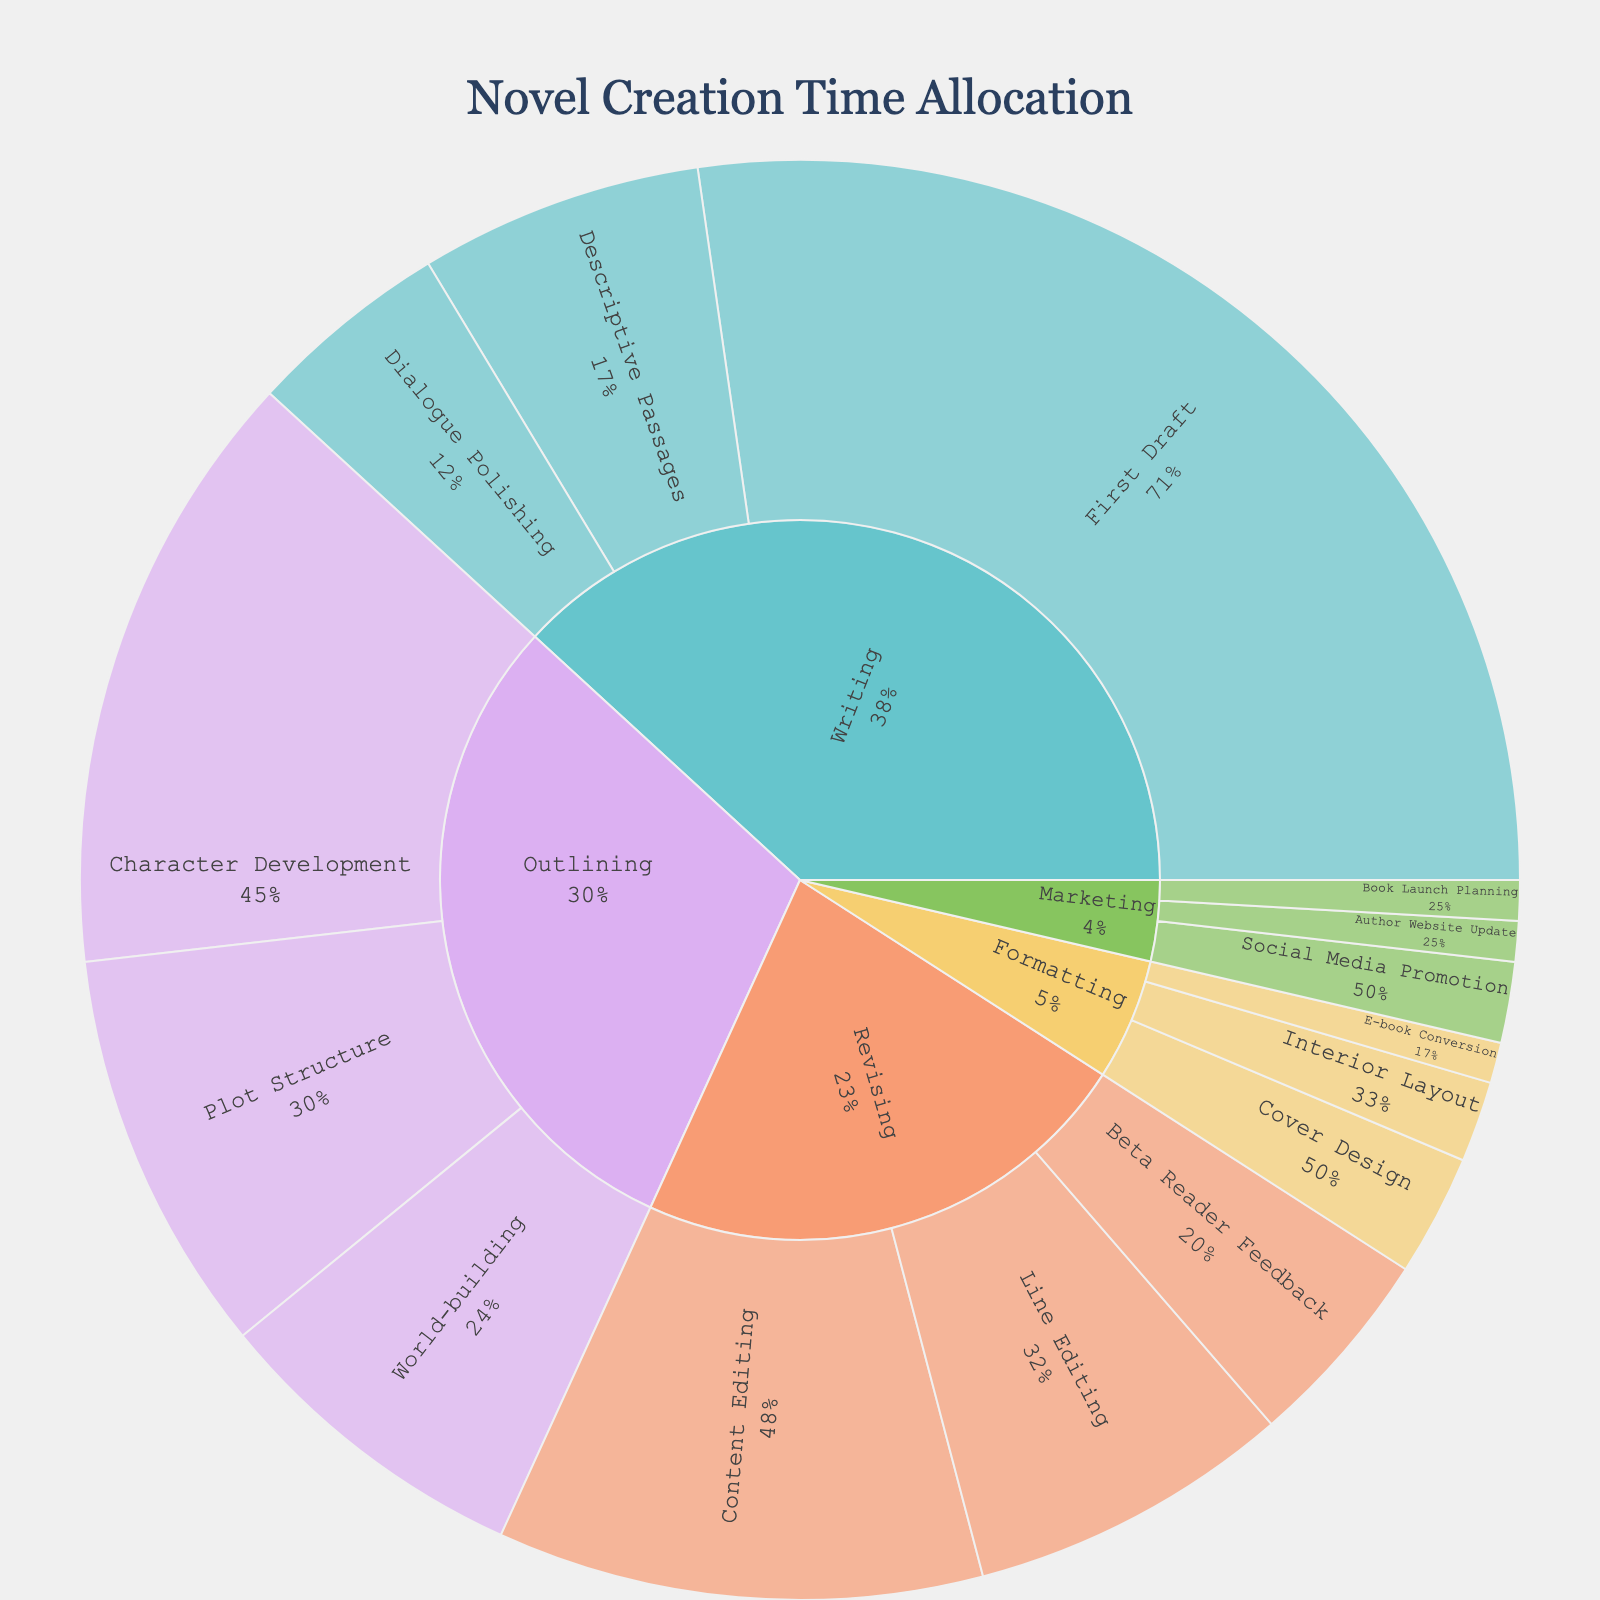What's the main title of the Sunburst Plot? Look at the top of the plot where the title is usually displayed to find the main title.
Answer: Novel Creation Time Allocation What color scheme is used for differentiating the phases in the Sunburst Plot? Observe the colors assigned to each phase in the plot. The plot uses a pastel color scheme, which can be inferred from the light and soft colors.
Answer: Pastel Which phase has the largest time allocation? Look at the central sections of the sunburst plot to identify which phase occupies the largest sized segment. The size of the “Writing” phase is the largest.
Answer: Writing How much total time is allocated to the ‘Outlining’ phase? Sum the time allocations for the subphases under the 'Outlining' phase: Character Development (15), Plot Structure (10), and World-building (8). The total is 15 + 10 + 8 = 33 hours.
Answer: 33 hours What is the smallest time allocation for any subphase, and which subphase is it? To find the smallest slice in the sunburst plot, check the subphase with the least space. The smallest time allocation is 1 hour each for 'E-book Conversion', 'Book Launch Planning', and 'Author Website Update'.
Answer: 1 hour; E-book Conversion, Book Launch Planning, Author Website Update How does the time allocated to ‘First Draft’ compare to the entire ‘Revising’ phase? Calculate the total time for the ‘Revising’ phase by adding Content Editing (12), Line Editing (8), and Beta Reader Feedback (5). The total is 12 + 8 + 5 = 25 hours. Compare it to the time allocated to ‘First Draft’, which is 30 hours.
Answer: First Draft has 5 more hours than Revising What percentage of time within the ‘Outlining’ phase is allocated to ‘Character Development’? The time allocated to Character Development is 15 hours. The total for the ‘Outlining’ phase is 33 hours. The percentage is (15 / 33) * 100 = 45.5%.
Answer: 45.5% Which phase should get more focus if an author wants to reduce time based on its current allocation? Identify the phase with the largest overall time allocation. The ‘Writing’ phase, with 30+7+5=42 hours, is the largest, and hence, if reduction is desired, focusing here would be beneficial.
Answer: Writing phase How many subphases are within the ‘Marketing’ phase, and what are they? Count the individual segments under the 'Marketing' phase. They are Social Media Promotion, Book Launch Planning, and Author Website Update, which makes it three subphases.
Answer: 3 subphases: Social Media Promotion, Book Launch Planning, Author Website Update What is the total time spent on ‘Formatting’? Sum the time allocations for the subphases under the 'Formatting' phase: Cover Design (3), Interior Layout (2), and E-book Conversion (1). The total is 3 + 2 + 1 = 6 hours.
Answer: 6 hours 